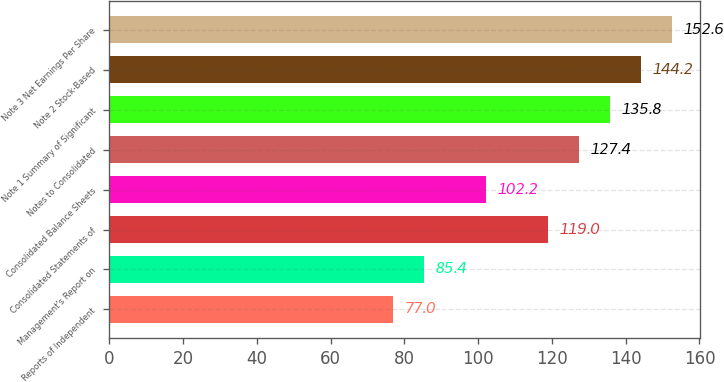Convert chart. <chart><loc_0><loc_0><loc_500><loc_500><bar_chart><fcel>Reports of Independent<fcel>Management's Report on<fcel>Consolidated Statements of<fcel>Consolidated Balance Sheets<fcel>Notes to Consolidated<fcel>Note 1 Summary of Significant<fcel>Note 2 Stock-Based<fcel>Note 3 Net Earnings Per Share<nl><fcel>77<fcel>85.4<fcel>119<fcel>102.2<fcel>127.4<fcel>135.8<fcel>144.2<fcel>152.6<nl></chart> 